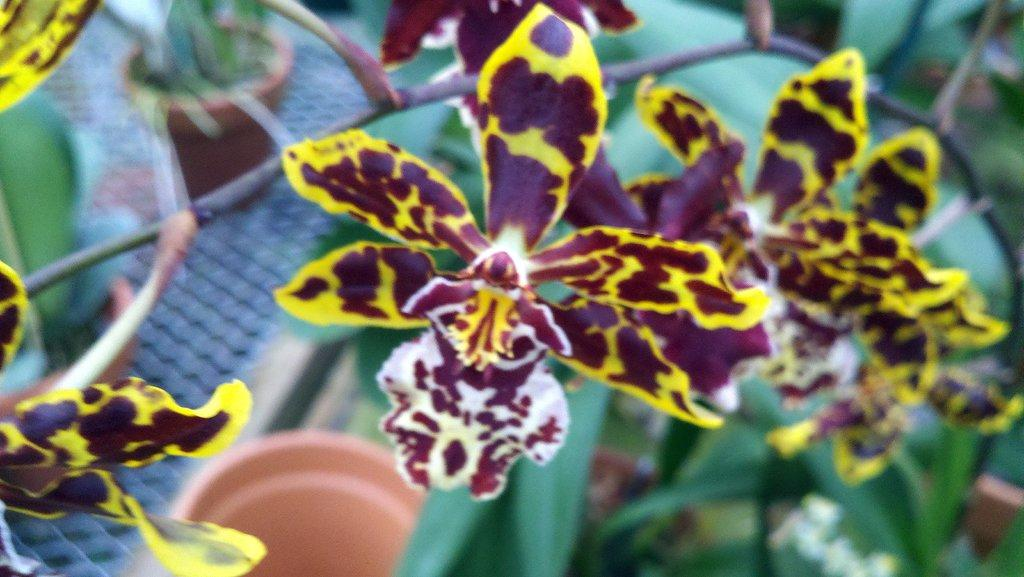What type of plants can be seen in the image? There are flowering plants in the image. Where are the flowering plants located? The flowering plants are in pots on the floor in the image. Can you determine the time of day the image was taken? The image was likely taken during the day, as there is sufficient light to see the flowering plants and pots clearly. What type of minister is present in the image? There is no minister present in the image; it features flowering plants in pots on the floor. Can you tell me how many houses are visible in the image? There are no houses visible in the image; it focuses on flowering plants in pots on the floor. 